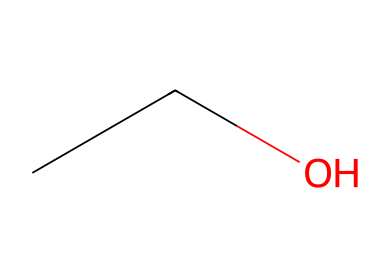What is the molecular formula of this compound? The SMILES representation "CCO" indicates there are two carbon atoms (C) and six hydrogen atoms (H) with one oxygen atom (O), leading to the molecular formula C2H6O.
Answer: C2H6O How many carbon atoms are in ethanol? The structure represented in the SMILES "CCO" shows two 'C' symbols, indicating that there are two carbon atoms in the compound.
Answer: 2 What type of functional group is present in ethanol? The "O" in the SMILES "CCO" denotes a hydroxyl functional group (-OH), which is characteristic for alcohols, including ethanol.
Answer: hydroxyl What is the total number of atoms in ethanol? Counting from the SMILES "CCO", there are 2 carbon atoms, 6 hydrogen atoms, and 1 oxygen atom. Adding these gives a total of 9 atoms.
Answer: 9 How many hydrogen atoms are connected to the central carbon in ethanol? In the structure represented by SMILES "CCO", the first carbon atom is connected to three hydrogen atoms, while the second carbon is attached to two hydrogen atoms and one hydroxyl group. Hence, the first carbon has three hydrogen atoms connected.
Answer: 3 Is ethanol a type of alcohol? Ethanol, represented by the SMILES "CCO", is indeed classified as an alcohol due to the presence of the hydroxyl functional group.
Answer: yes 